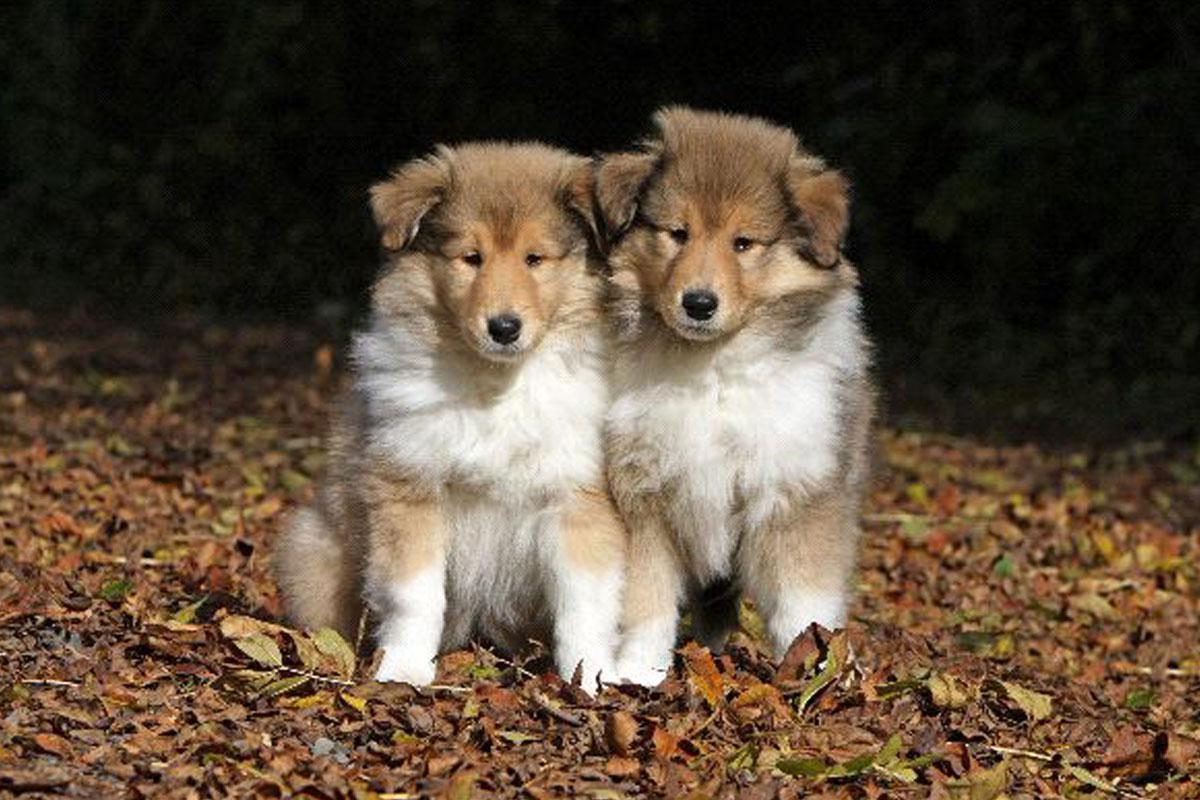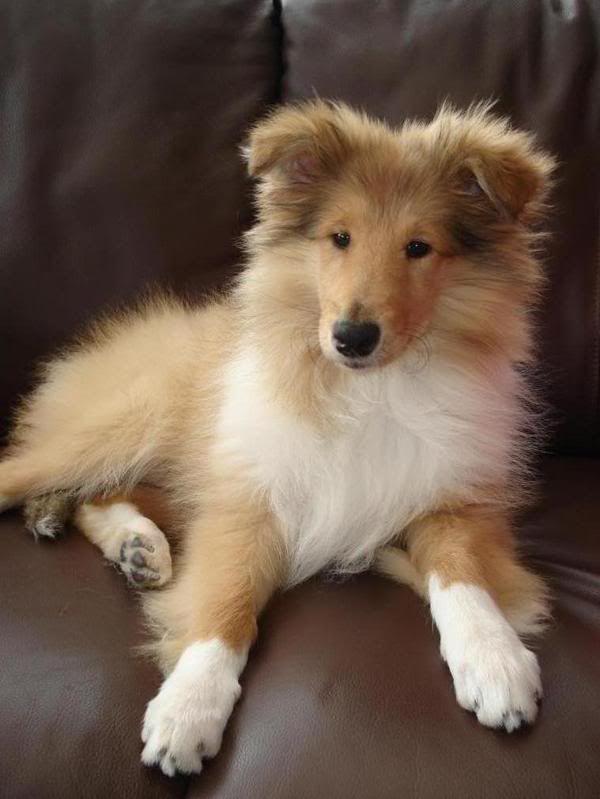The first image is the image on the left, the second image is the image on the right. Given the left and right images, does the statement "Young collies are posed sitting upright side-by-side in one image, and the other image shows one collie reclining with its head upright." hold true? Answer yes or no. Yes. The first image is the image on the left, the second image is the image on the right. Examine the images to the left and right. Is the description "The left image contains exactly two dogs." accurate? Answer yes or no. Yes. 